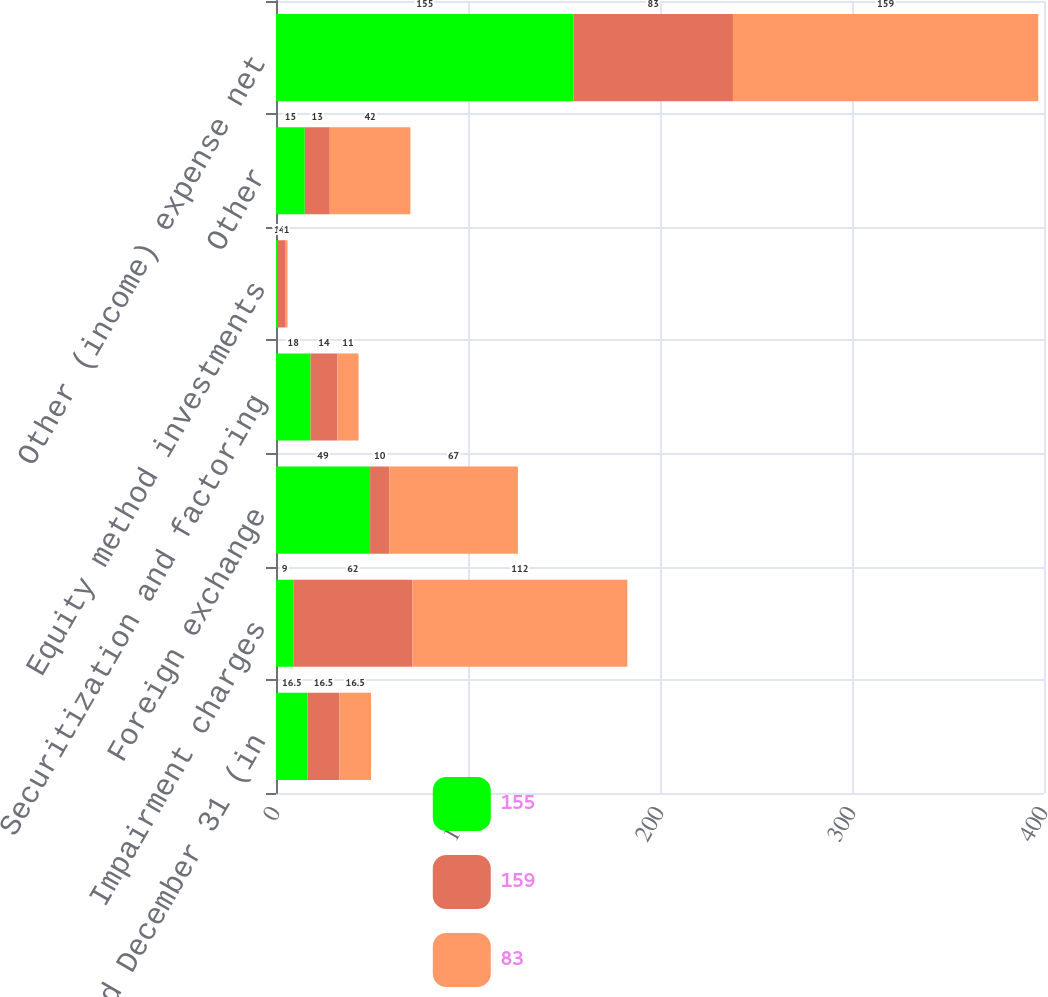Convert chart to OTSL. <chart><loc_0><loc_0><loc_500><loc_500><stacked_bar_chart><ecel><fcel>years ended December 31 (in<fcel>Impairment charges<fcel>Foreign exchange<fcel>Securitization and factoring<fcel>Equity method investments<fcel>Other<fcel>Other (income) expense net<nl><fcel>155<fcel>16.5<fcel>9<fcel>49<fcel>18<fcel>1<fcel>15<fcel>155<nl><fcel>159<fcel>16.5<fcel>62<fcel>10<fcel>14<fcel>4<fcel>13<fcel>83<nl><fcel>83<fcel>16.5<fcel>112<fcel>67<fcel>11<fcel>1<fcel>42<fcel>159<nl></chart> 